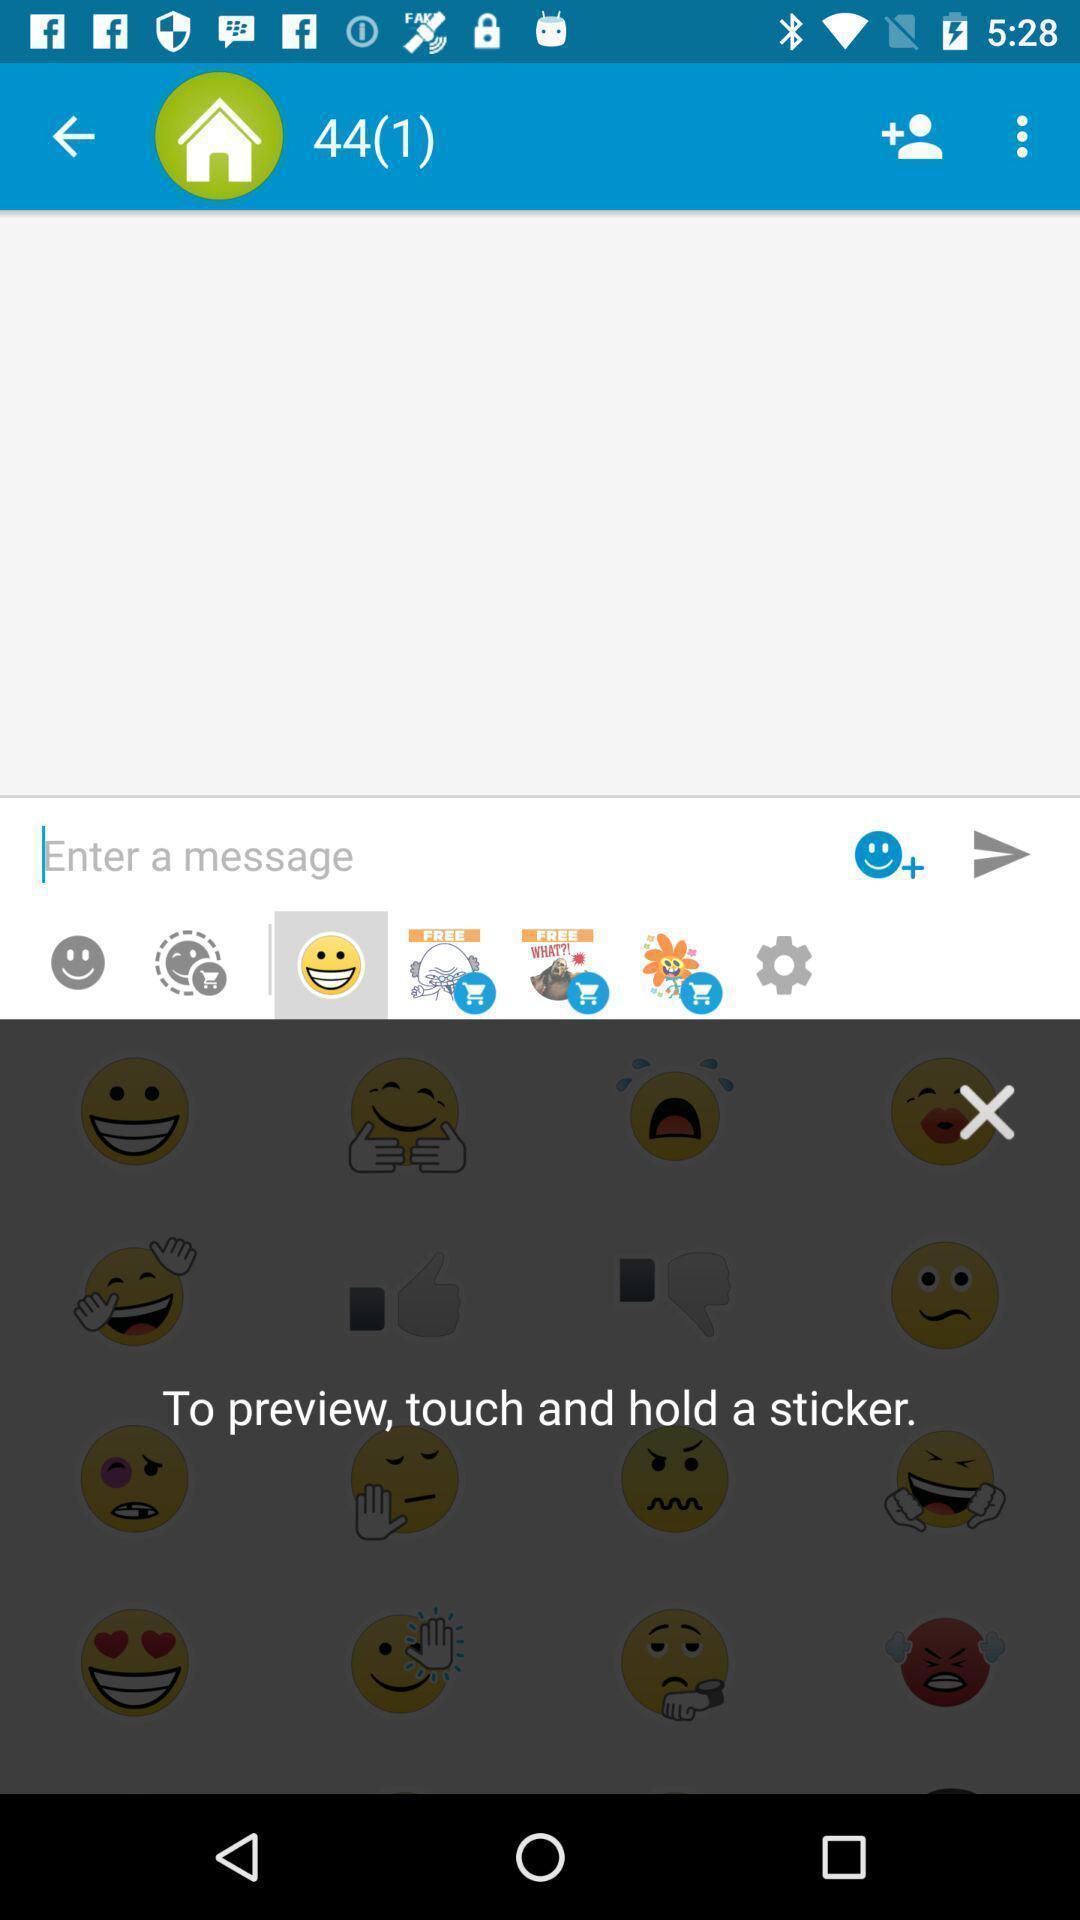Provide a detailed account of this screenshot. Pop-up for to preview touch and hold a sticker. 